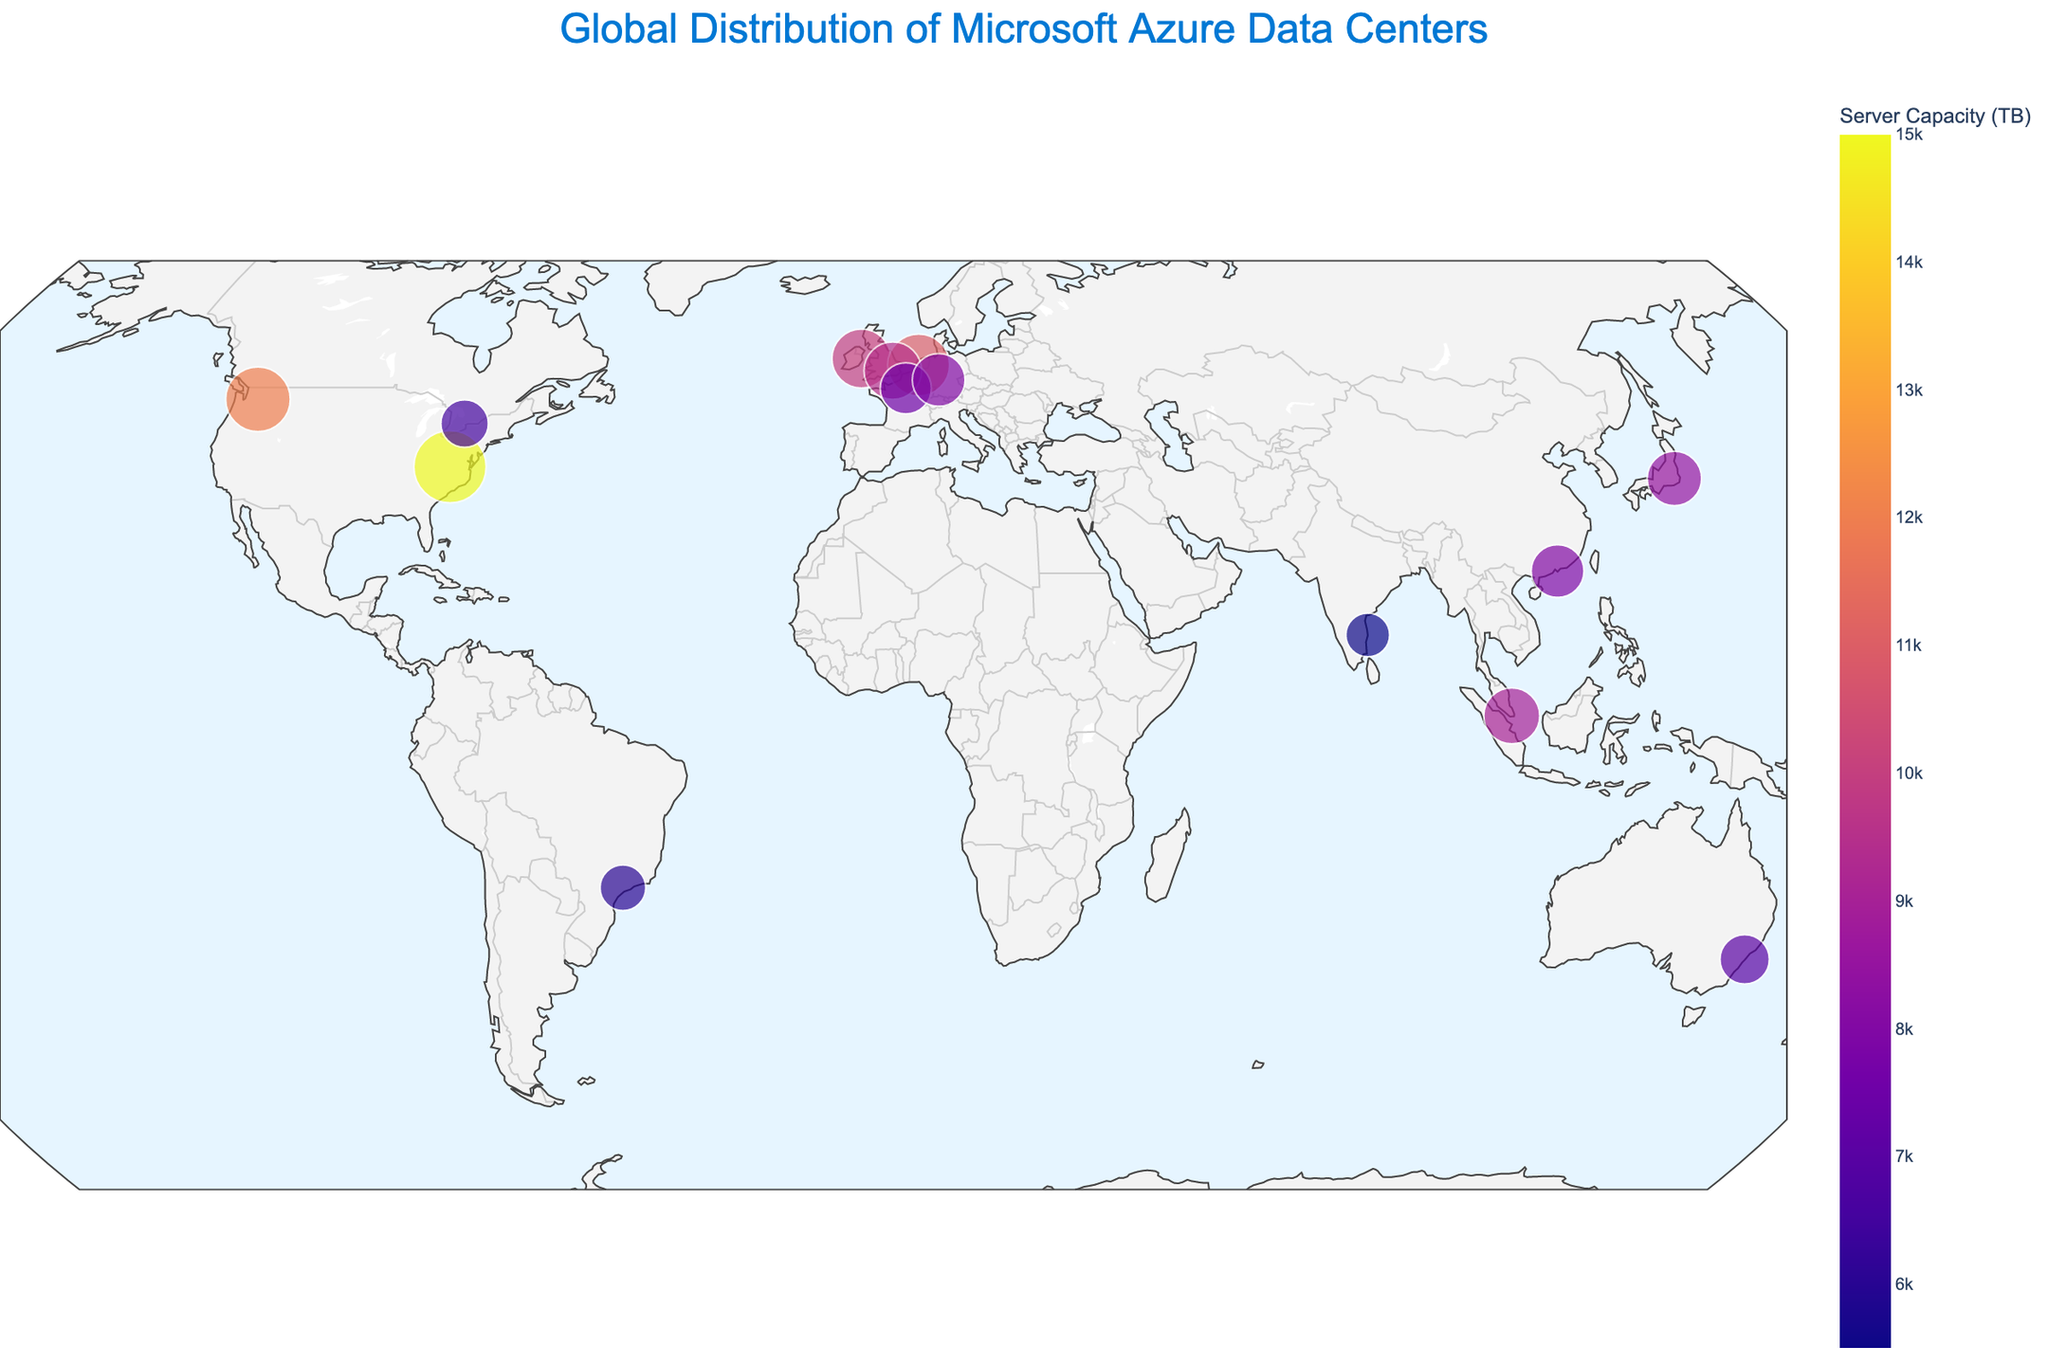How many data centers are displayed on the plot? Count the number of distinct points on the map.
Answer: 14 Which city has the highest server capacity? Look for the largest bubble and check the annotation or hover information for the city name.
Answer: Virginia Which continent has the most data centers? Identify and count the data centers in each continent.
Answer: North America What is the total server capacity for the European cities? Sum the server capacities for Dublin, Amsterdam, London, Paris, and Frankfurt. (10000 + 11000 + 9500 + 7500 + 8000 = 46000)
Answer: 46000 TB Which two cities are closest to each other geographically? Observe the plot and identify the two points that are closest to each other.
Answer: Paris and Frankfurt How does the server capacity of Tokyo compare to that of Singapore? Compare the size (or the value shown in the hover information) of the Tokyo and Singapore bubbles.
Answer: Tokyo has higher capacity Which city has the lowest server capacity in the dataset? Look for the smallest bubble and check the annotation or hover information for the city name.
Answer: Chennai What is the average server capacity of the data centers in North America? Calculate the average of server capacities in Virginia, Washington, and Toronto. (15000 + 12000 + 6500) / 3 = 11166.67
Answer: 11166.67 TB How many data centers are located in Asia? Count the number of data centers in Hong Kong, Tokyo, Singapore, and Chennai.
Answer: 4 What is the range of server capacities across all data centers? Subtract the smallest server capacity (Chennai: 5500 TB) from the largest (Virginia: 15000 TB). 15000 - 5500 = 9500
Answer: 9500 TB 